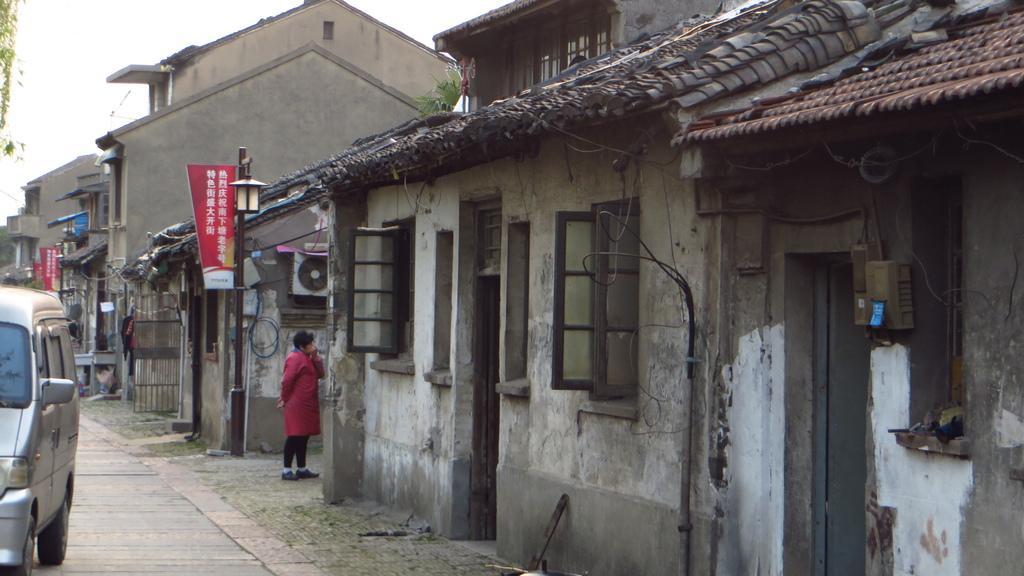How would you summarize this image in a sentence or two? In this image we can see there are buildings, light pole and board attached to it. And there is a person standing on the ground. And there are clothes, tree and the sky. And there is a vehicle on the road. 